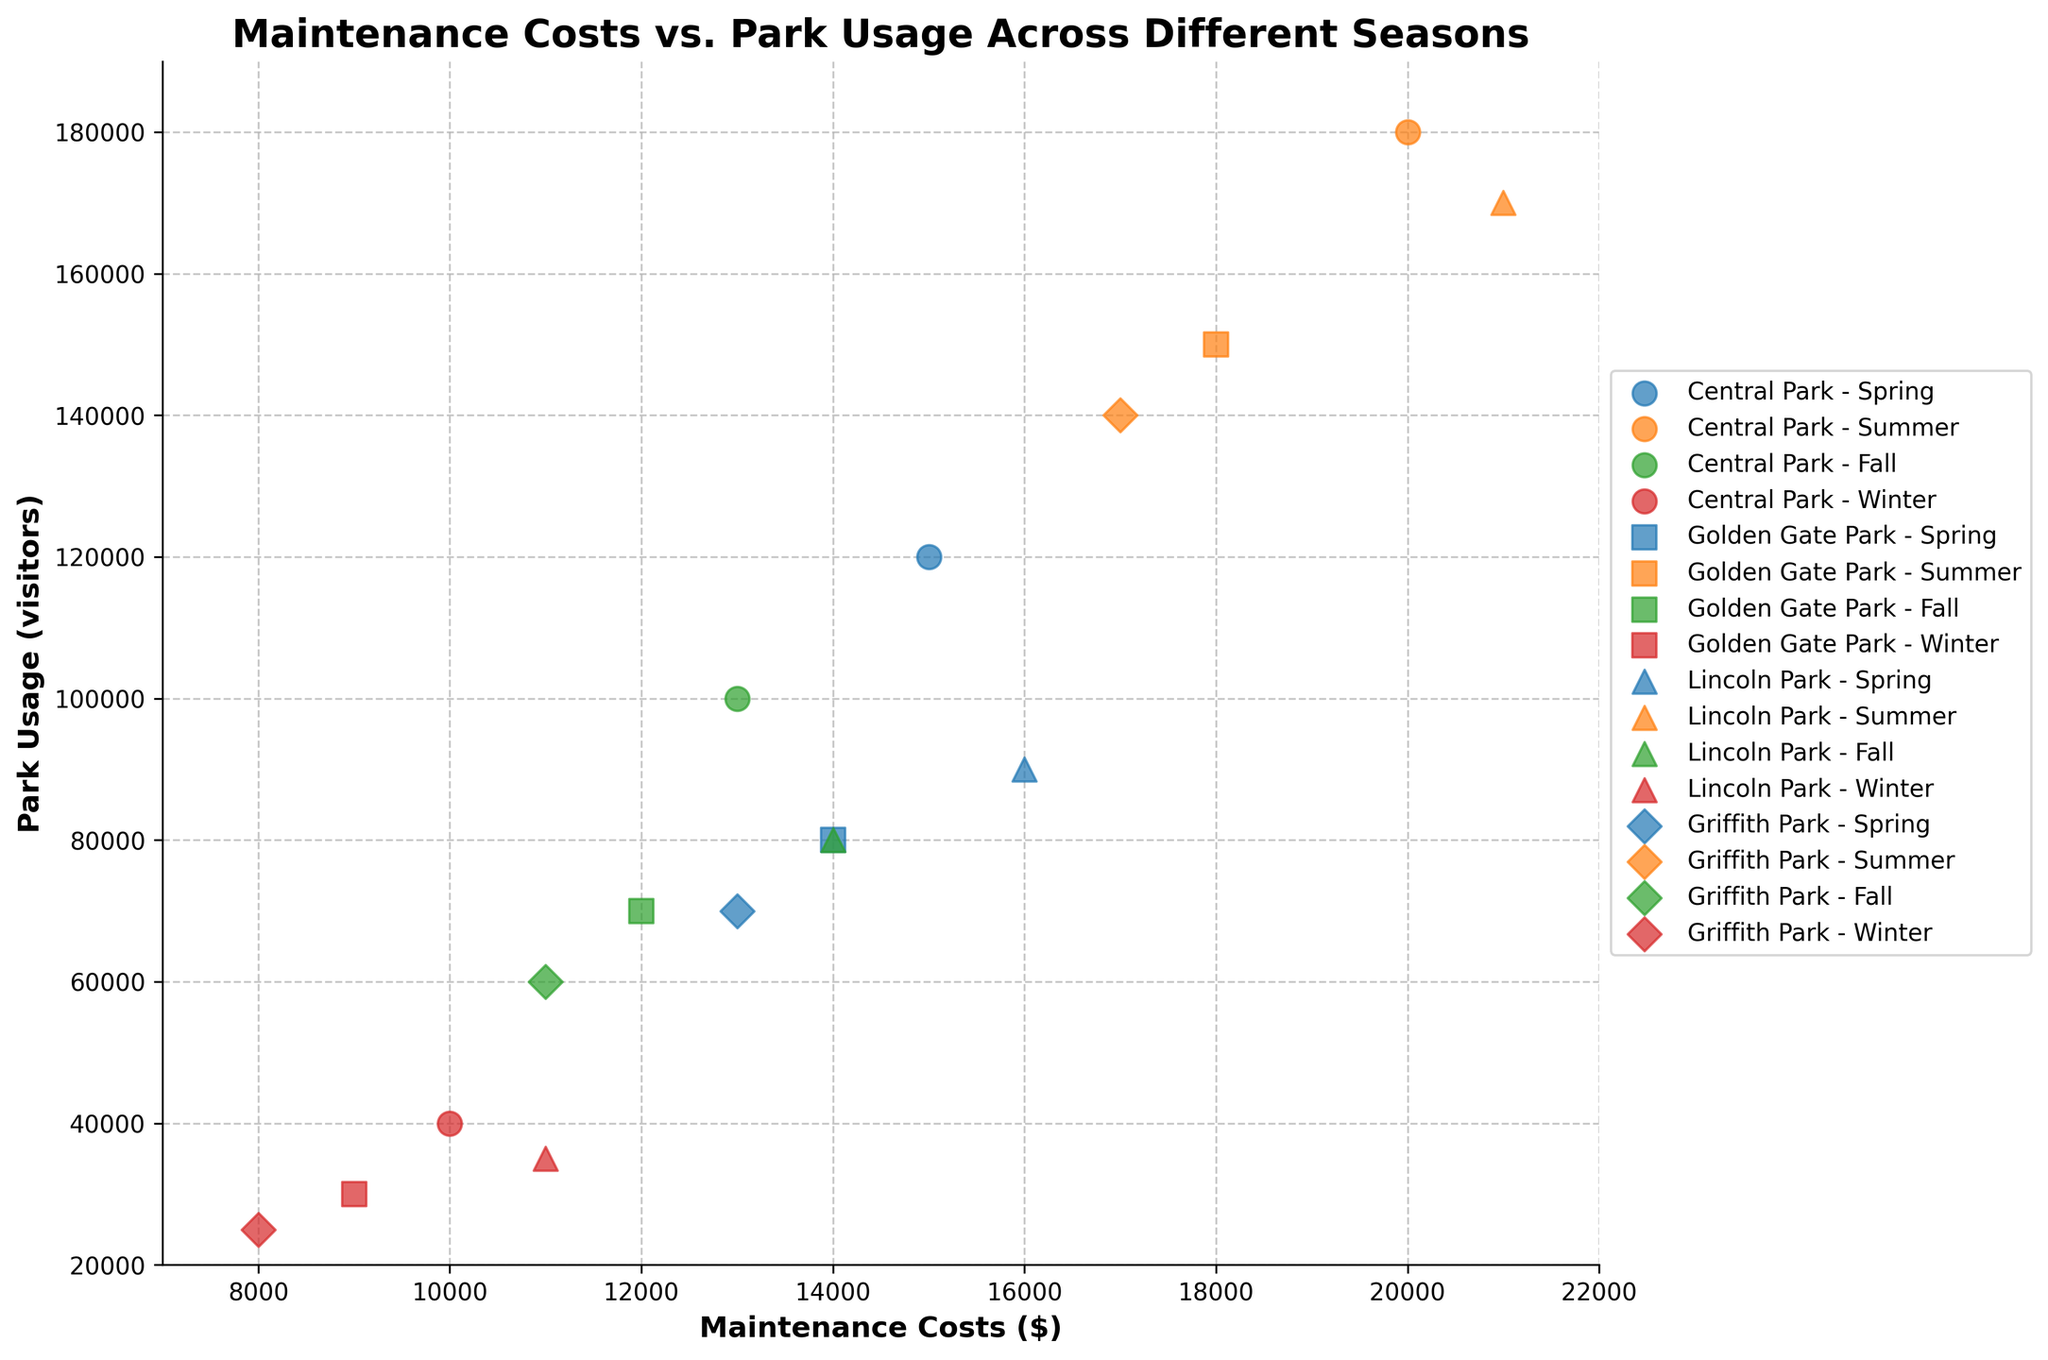What's the title of the figure? The title is displayed at the top center of the figure. It provides a summary of what the scatter plot depicts, which helps viewers understand the context of the data.
Answer: Maintenance Costs vs. Park Usage Across Different Seasons What is the range of Maintenance Costs displayed on the x-axis? The x-axis represents the Maintenance Costs. The range can be found by looking at the minimum and maximum values shown on this axis.
Answer: 7000 to 22000 Which park has the highest park usage in the winter season? Each park's data points across different seasons are plotted with different markers. To find the highest park usage in winter, we look for the winter data points and compare their y-values.
Answer: Central Park What is the average park usage for Lincoln Park throughout all seasons? To find the average park usage for Lincoln Park, sum its park usage values for all seasons and then divide by the number of seasons. Lincoln Park's park usage values are 90000, 170000, 80000, and 35000. (90000 + 170000 + 80000 + 35000) / 4 = 93750.
Answer: 93750 Which season generally incurs the highest maintenance costs across all parks? Each season has different colors for data points. By visually identifying the season with the consistently highest x-axis values across all parks, we determine the season.
Answer: Summer How does the maintenance cost for Griffith Park in summer compare to its cost in winter? Look at the x-axis values for Griffith Park's summer and winter markers and compare them. Griffith Park's maintenance costs in summer and winter are 17000 and 8000 respectively.
Answer: Higher in summer Are there any parks where park usage increases but maintenance costs decrease in the fall season compared to summer? Look for patterns by comparing summer and fall data points of each park. We check the x-axis (costs) and y-axis (usage) values for all parks from summer to fall. None of the parks show increased usage with decreased costs in fall.
Answer: No Which park shows the least variation in maintenance costs across different seasons? Comparing the spread of the x-axis values for each park across all seasons, we look for the park whose data points are closest together horizontally.
Answer: Golden Gate Park What is the difference in park usage between the park with the highest usage in spring and the park with the lowest usage in winter? Identify the highest spring usage and lowest winter usage data points and subtract the latter from the former. Central Park has the highest spring usage (120000), and Griffith Park has the lowest winter usage (25000). 120000 - 25000 = 95000.
Answer: 95000 Which season has the most consistent maintenance costs across different parks? We check the spread in the x-axis values for each season across different parks. The season with the smallest spread in maintenance costs indicates consistency.
Answer: Winter 